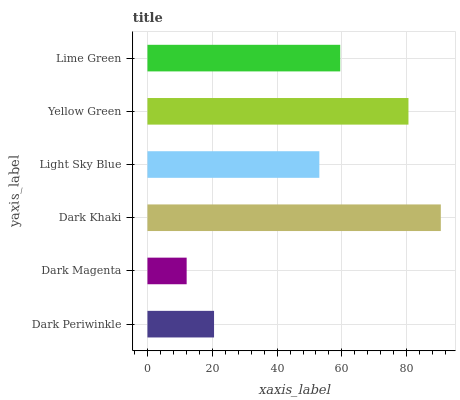Is Dark Magenta the minimum?
Answer yes or no. Yes. Is Dark Khaki the maximum?
Answer yes or no. Yes. Is Dark Khaki the minimum?
Answer yes or no. No. Is Dark Magenta the maximum?
Answer yes or no. No. Is Dark Khaki greater than Dark Magenta?
Answer yes or no. Yes. Is Dark Magenta less than Dark Khaki?
Answer yes or no. Yes. Is Dark Magenta greater than Dark Khaki?
Answer yes or no. No. Is Dark Khaki less than Dark Magenta?
Answer yes or no. No. Is Lime Green the high median?
Answer yes or no. Yes. Is Light Sky Blue the low median?
Answer yes or no. Yes. Is Dark Magenta the high median?
Answer yes or no. No. Is Dark Periwinkle the low median?
Answer yes or no. No. 